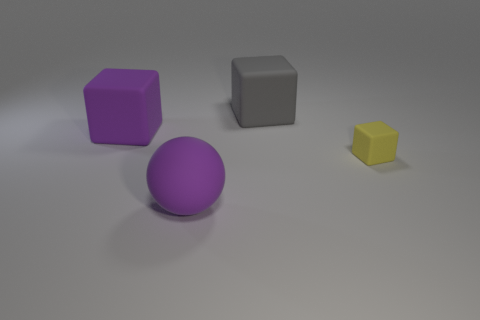Is the number of rubber blocks that are in front of the matte ball greater than the number of gray matte spheres?
Make the answer very short. No. What number of other yellow objects have the same size as the yellow object?
Your answer should be compact. 0. What size is the rubber object that is the same color as the sphere?
Your answer should be very brief. Large. What number of large objects are balls or purple matte cubes?
Keep it short and to the point. 2. How many rubber objects are there?
Make the answer very short. 4. Is the number of rubber things that are behind the large sphere the same as the number of gray matte cubes to the right of the tiny yellow rubber cube?
Ensure brevity in your answer.  No. There is a yellow block; are there any big matte things right of it?
Provide a short and direct response. No. What is the color of the big thing in front of the tiny yellow cube?
Your response must be concise. Purple. What material is the large thing that is in front of the cube to the left of the gray rubber cube?
Provide a short and direct response. Rubber. Is the number of big matte objects to the right of the tiny cube less than the number of tiny rubber objects that are to the left of the big gray cube?
Provide a succinct answer. No. 